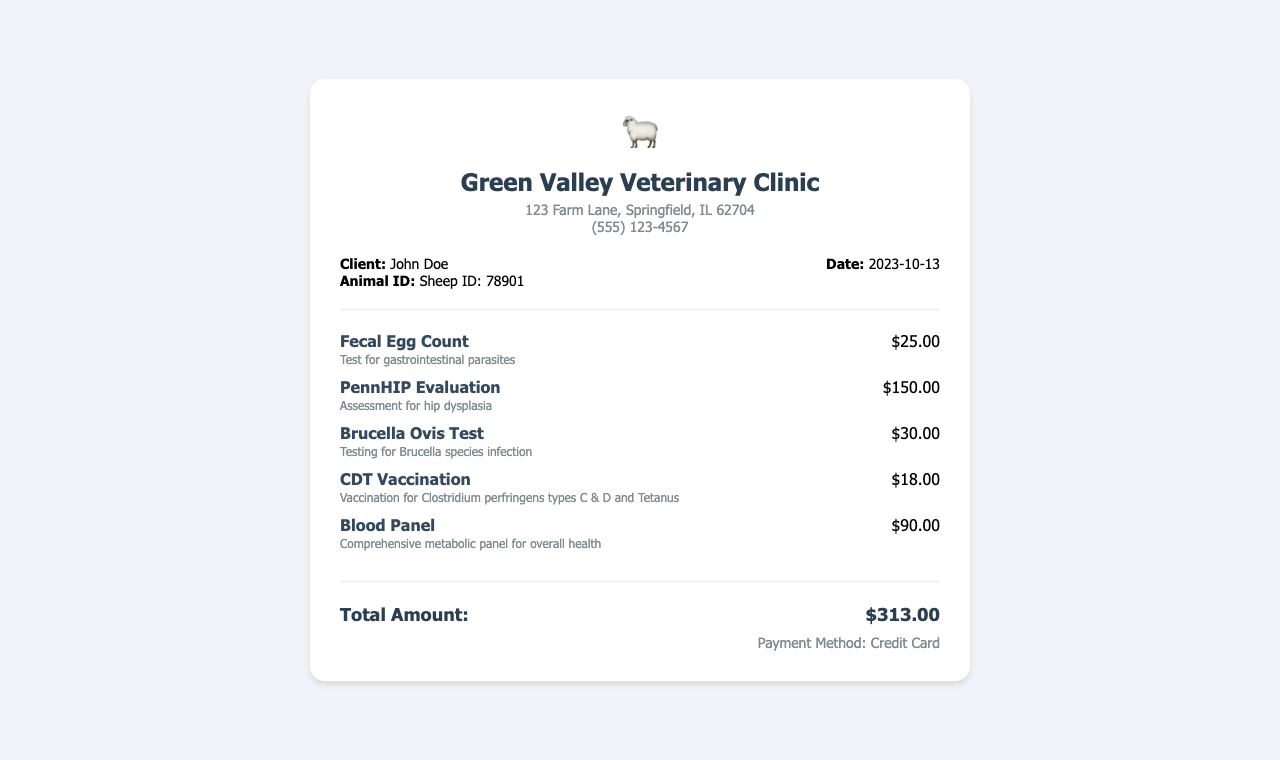what is the clinic name? The clinic name is provided in the header of the document.
Answer: Green Valley Veterinary Clinic who is the client? The client's name is listed under the client details section.
Answer: John Doe what is the date of the service? The date is specified in the client details section of the document.
Answer: 2023-10-13 how much does the Fecal Egg Count cost? The cost of the Fecal Egg Count is mentioned next to the service name.
Answer: $25.00 what is the total amount billed? The total amount is located in the total section at the end of the receipt.
Answer: $313.00 how many tests were performed? The number of tests can be counted from the services section.
Answer: 5 which payment method was used? The payment method is stated in the payment method section of the document.
Answer: Credit Card what type of vaccination was given? The vaccination type is noted in the services section under CDT Vaccination.
Answer: CDT Vaccination what is the service description for the Blood Panel? The service description for the Blood Panel test is listed right below its service name.
Answer: Comprehensive metabolic panel for overall health 